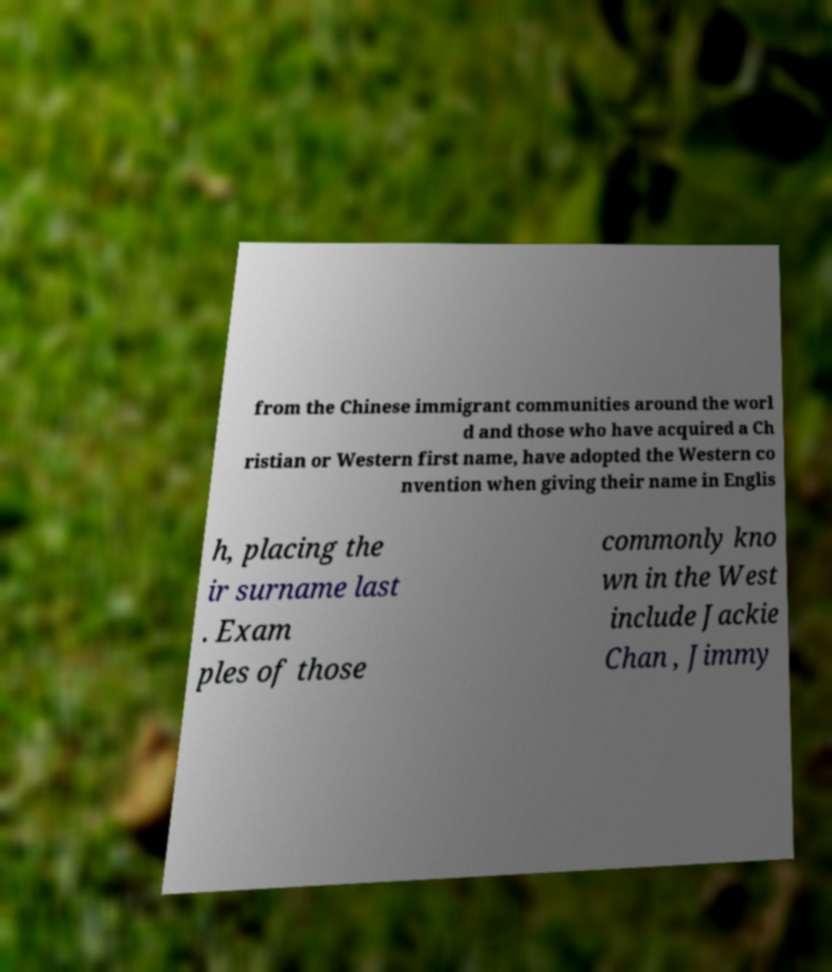Please identify and transcribe the text found in this image. from the Chinese immigrant communities around the worl d and those who have acquired a Ch ristian or Western first name, have adopted the Western co nvention when giving their name in Englis h, placing the ir surname last . Exam ples of those commonly kno wn in the West include Jackie Chan , Jimmy 